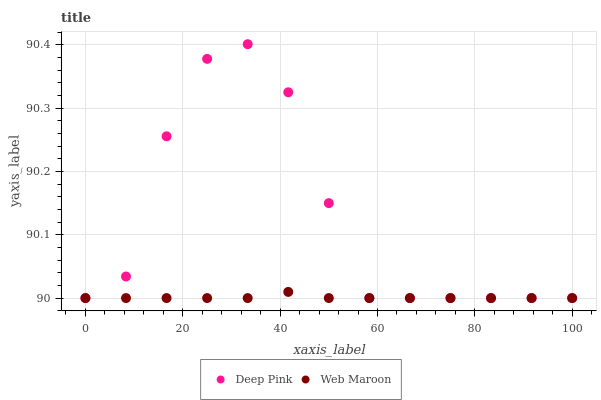Does Web Maroon have the minimum area under the curve?
Answer yes or no. Yes. Does Deep Pink have the maximum area under the curve?
Answer yes or no. Yes. Does Web Maroon have the maximum area under the curve?
Answer yes or no. No. Is Web Maroon the smoothest?
Answer yes or no. Yes. Is Deep Pink the roughest?
Answer yes or no. Yes. Is Web Maroon the roughest?
Answer yes or no. No. Does Deep Pink have the lowest value?
Answer yes or no. Yes. Does Deep Pink have the highest value?
Answer yes or no. Yes. Does Web Maroon have the highest value?
Answer yes or no. No. Does Deep Pink intersect Web Maroon?
Answer yes or no. Yes. Is Deep Pink less than Web Maroon?
Answer yes or no. No. Is Deep Pink greater than Web Maroon?
Answer yes or no. No. 